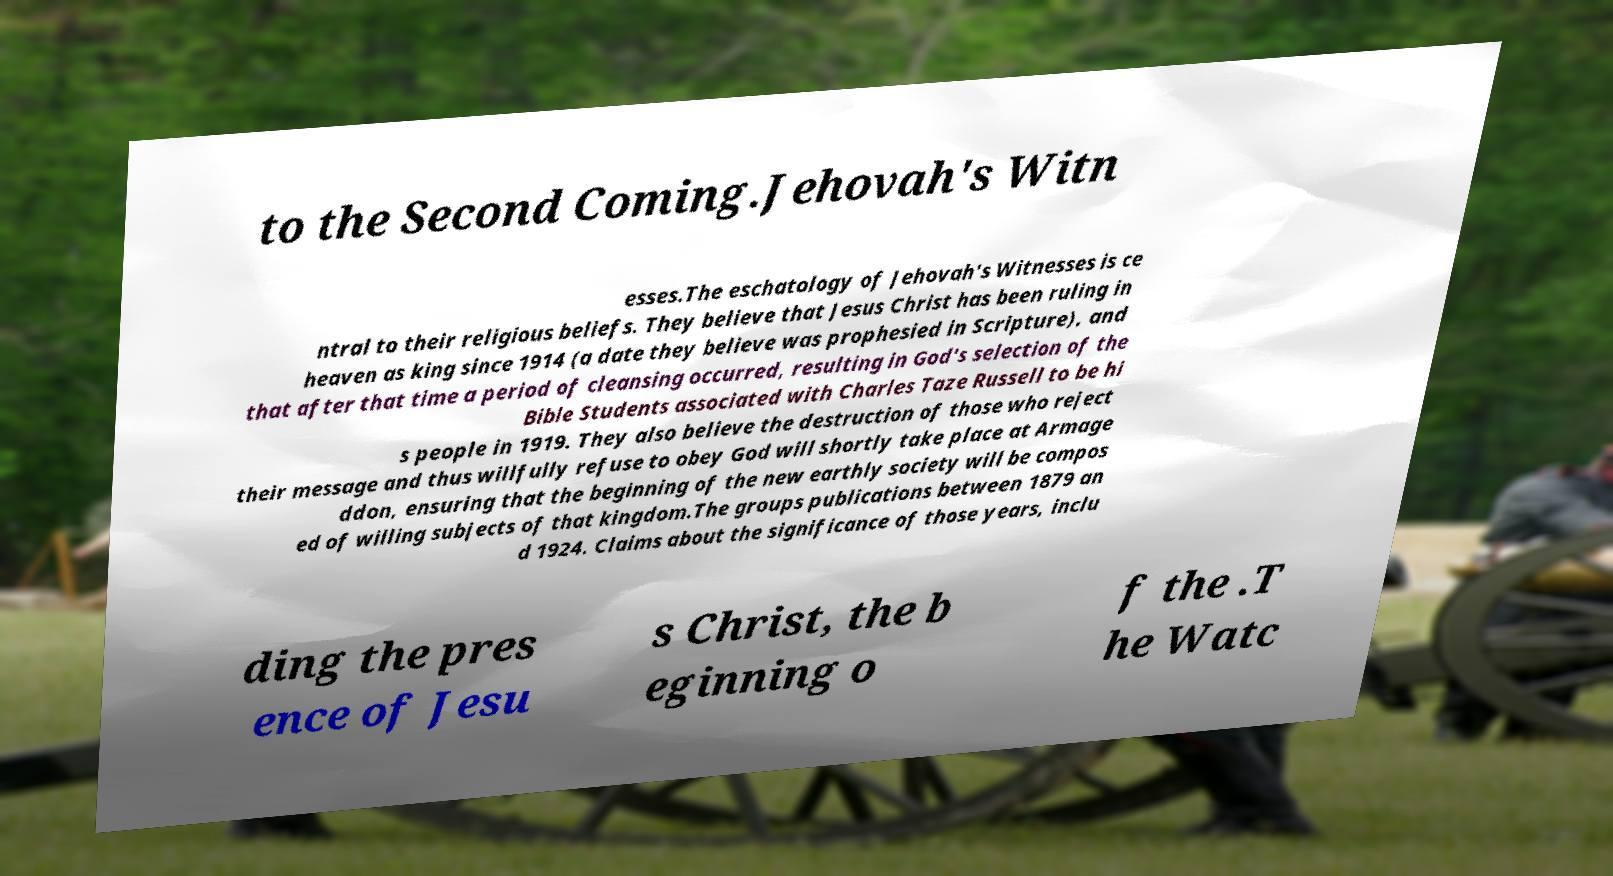Can you read and provide the text displayed in the image?This photo seems to have some interesting text. Can you extract and type it out for me? to the Second Coming.Jehovah's Witn esses.The eschatology of Jehovah's Witnesses is ce ntral to their religious beliefs. They believe that Jesus Christ has been ruling in heaven as king since 1914 (a date they believe was prophesied in Scripture), and that after that time a period of cleansing occurred, resulting in God's selection of the Bible Students associated with Charles Taze Russell to be hi s people in 1919. They also believe the destruction of those who reject their message and thus willfully refuse to obey God will shortly take place at Armage ddon, ensuring that the beginning of the new earthly society will be compos ed of willing subjects of that kingdom.The groups publications between 1879 an d 1924. Claims about the significance of those years, inclu ding the pres ence of Jesu s Christ, the b eginning o f the .T he Watc 